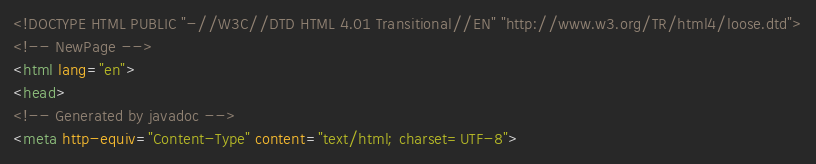<code> <loc_0><loc_0><loc_500><loc_500><_HTML_><!DOCTYPE HTML PUBLIC "-//W3C//DTD HTML 4.01 Transitional//EN" "http://www.w3.org/TR/html4/loose.dtd">
<!-- NewPage -->
<html lang="en">
<head>
<!-- Generated by javadoc -->
<meta http-equiv="Content-Type" content="text/html; charset=UTF-8"></code> 